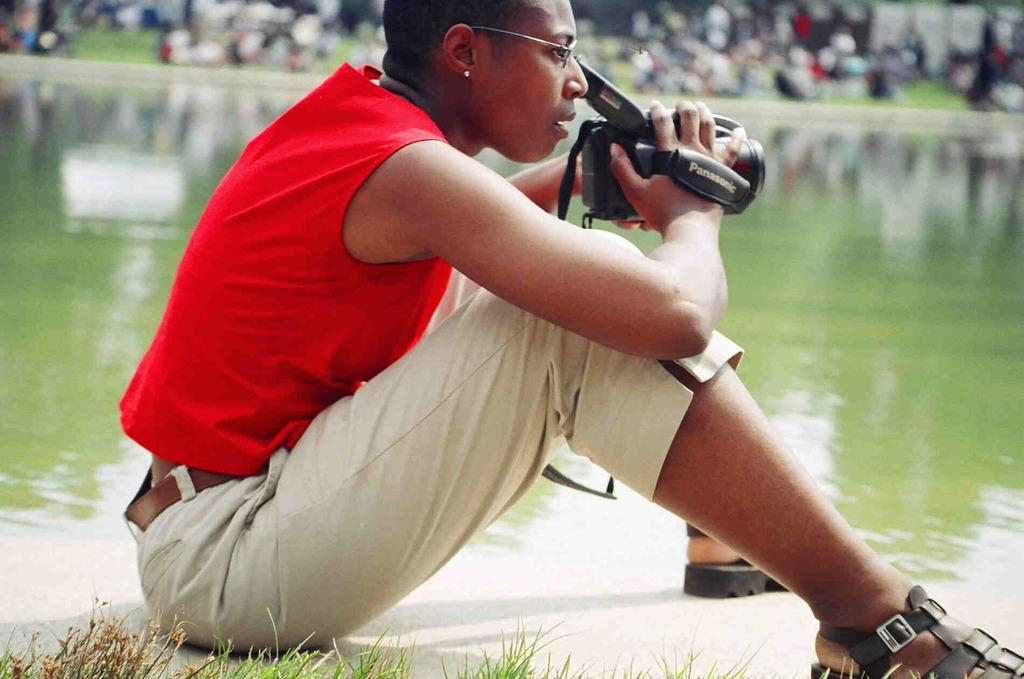What is the person in the image doing? The person is sitting on the ground and holding a video camera in her hand. What might the person be filming in the image? The presence of water in the image suggests that the person might be filming the water or the surrounding environment. Can you describe the background of the image? The background of the image is blurred. What color is the friction present in the image? There is no friction present in the image, and therefore no color can be attributed to it. 